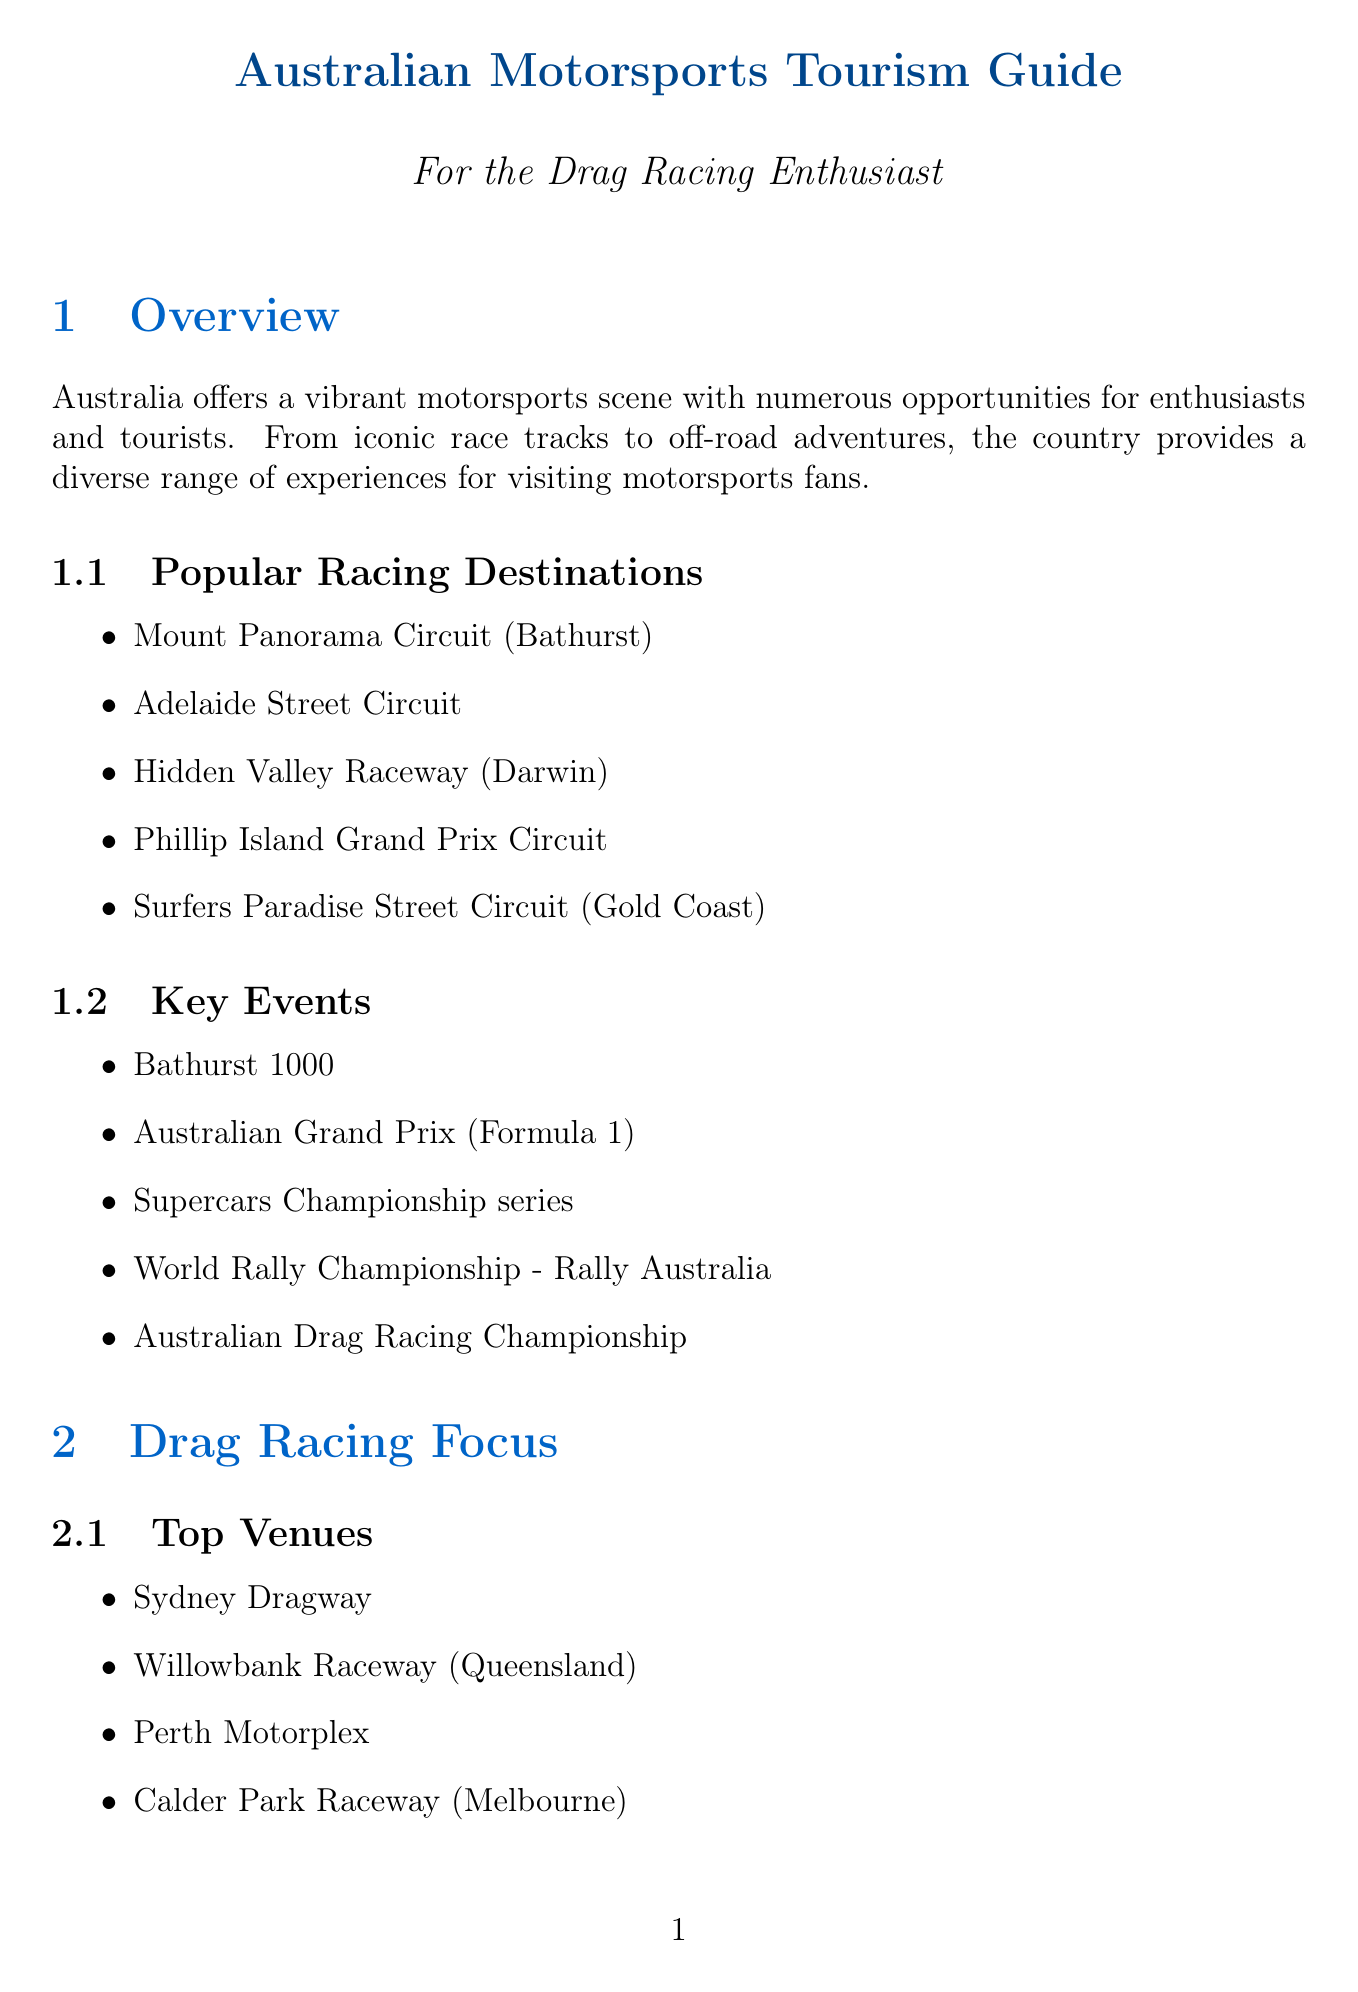What is the location of the Mount Panorama Circuit? The Mount Panorama Circuit is located in Bathurst, Australia.
Answer: Bathurst Name one notable event at Willowbank Raceway. The Winternationals is a notable event held at Willowbank Raceway.
Answer: Winternationals What is a tip for visitors interested in drag racing? Visitors are advised to check local regulations for participating in events.
Answer: Check local regulations List one local attraction in Gold Coast. The SkyPoint Observation Deck is a local attraction in Gold Coast.
Answer: SkyPoint Observation Deck What type of accommodation overlooks Mount Panorama Circuit? Rydges Mount Panorama Bathurst is an accommodation overlooking Mount Panorama Circuit.
Answer: Rydges Mount Panorama Bathurst Which racing event is part of the Supercars Championship series? The Supercars Championship series includes various races, one being Bathurst 1000.
Answer: Bathurst 1000 How many top venues for drag racing are listed in the document? There are four top venues for drag racing listed in the document.
Answer: Four What should visitors consider for better rates on flights? Visitors are advised to book flights in advance for better rates.
Answer: Book flights in advance 